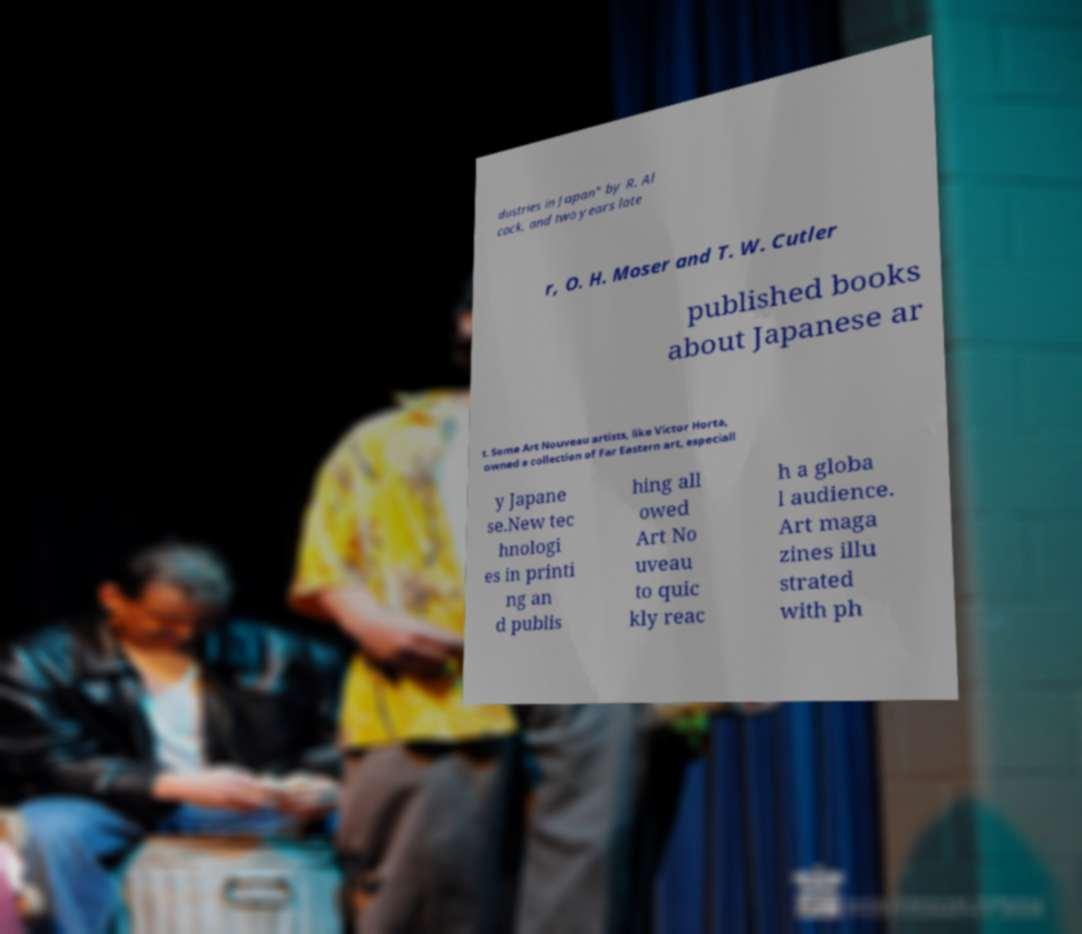Could you assist in decoding the text presented in this image and type it out clearly? dustries in Japan" by R. Al cock, and two years late r, O. H. Moser and T. W. Cutler published books about Japanese ar t. Some Art Nouveau artists, like Victor Horta, owned a collection of Far Eastern art, especiall y Japane se.New tec hnologi es in printi ng an d publis hing all owed Art No uveau to quic kly reac h a globa l audience. Art maga zines illu strated with ph 